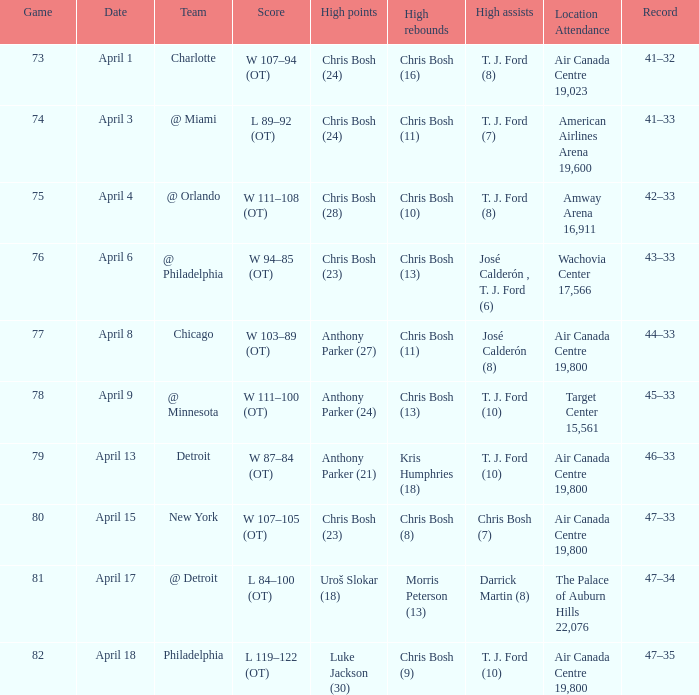What were the assists on april 8 in game not exceeding 78? José Calderón (8). 